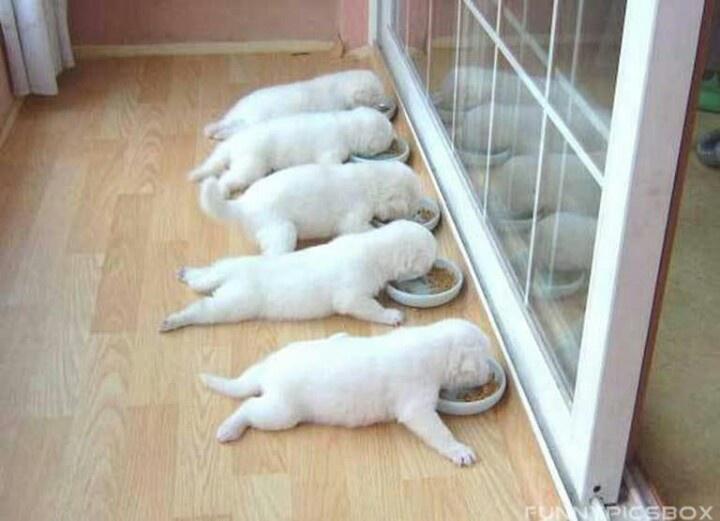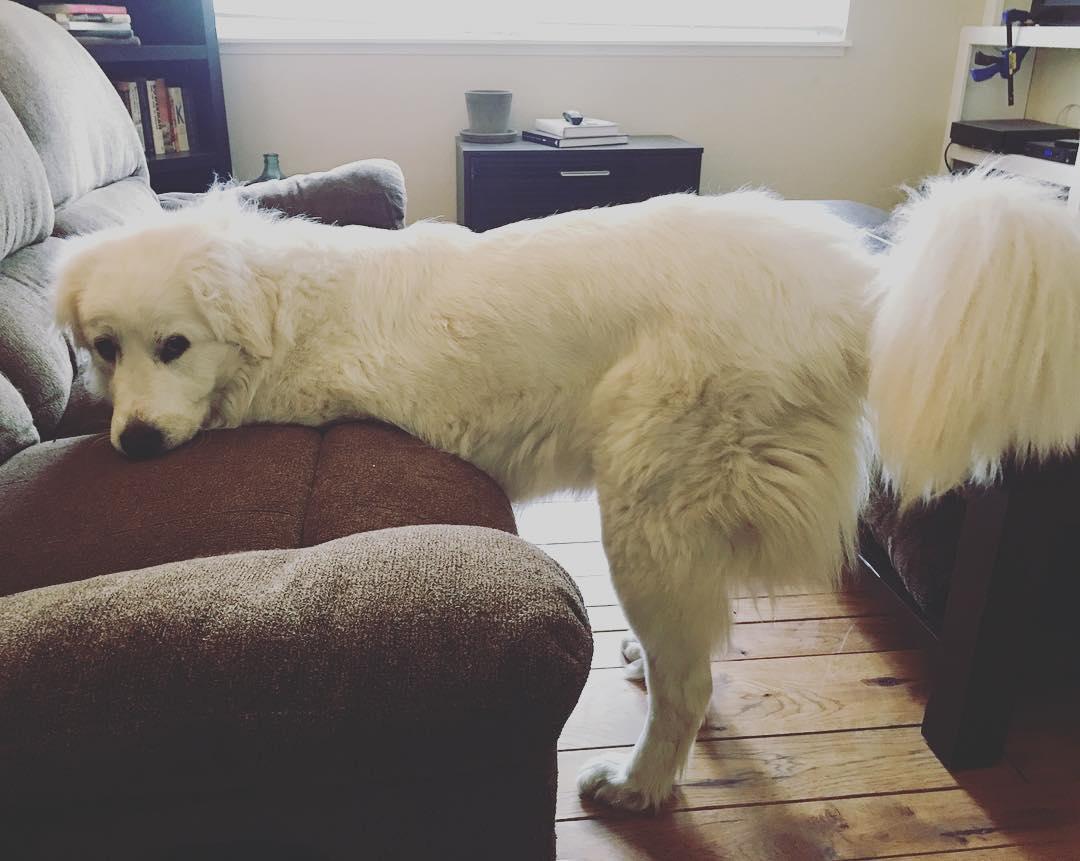The first image is the image on the left, the second image is the image on the right. Considering the images on both sides, is "An image shows a dog standing in front of a chair with only his hind legs on the floor." valid? Answer yes or no. Yes. The first image is the image on the left, the second image is the image on the right. Analyze the images presented: Is the assertion "At least four dogs are eating from bowls in the image on the left." valid? Answer yes or no. Yes. 